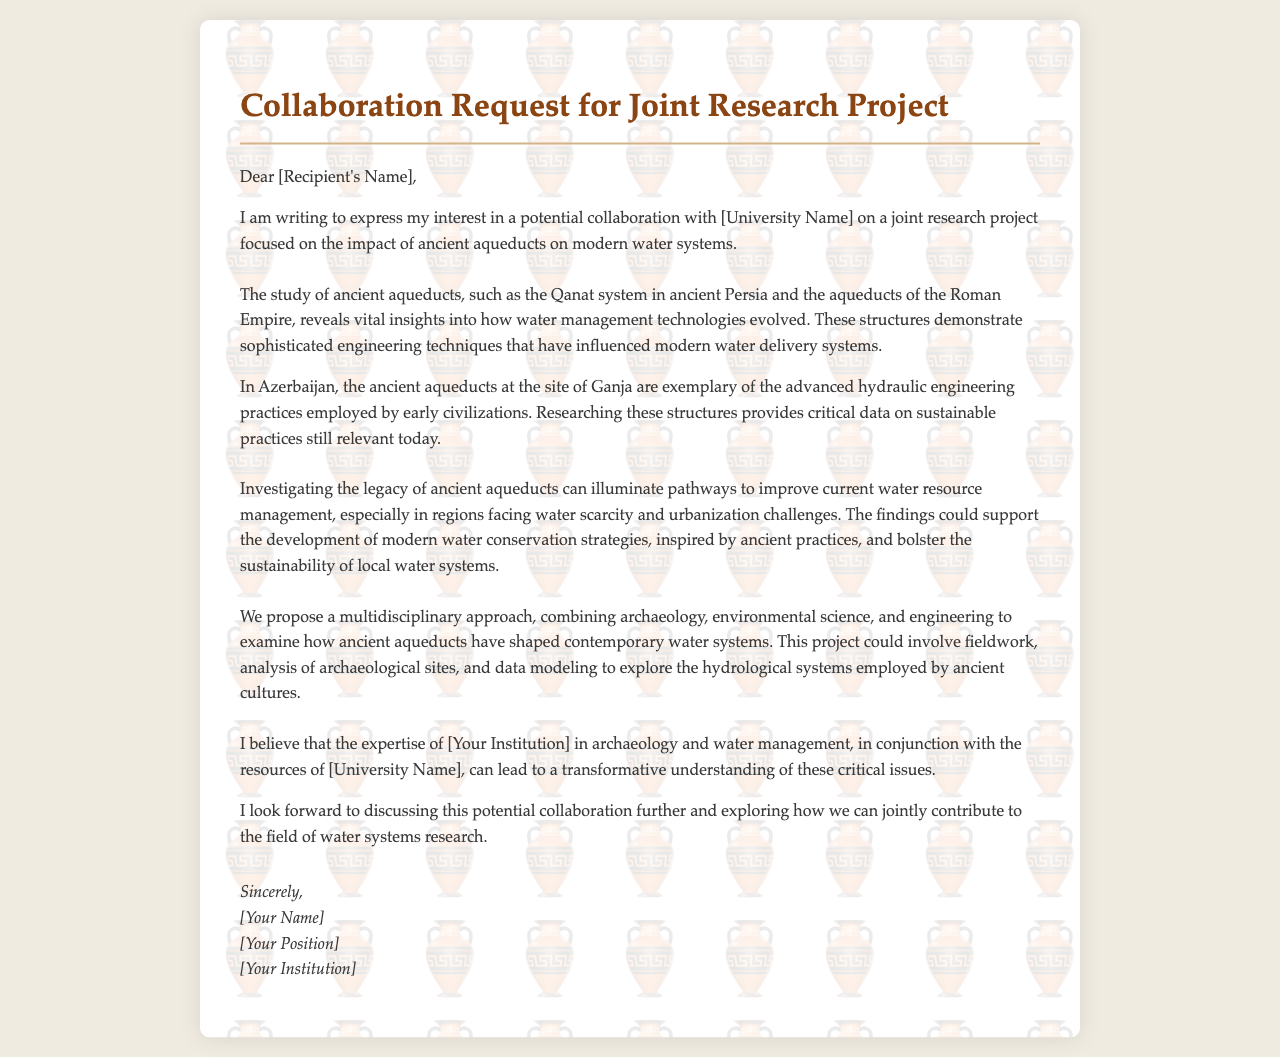What is the title of the document? The title is stated in the heading of the document and is "Collaboration Request for Joint Research Project."
Answer: Collaboration Request for Joint Research Project Who is the letter addressed to? The recipient's name is indicated in the opening line of the letter, which states "Dear [Recipient's Name]."
Answer: [Recipient's Name] What ancient aqueduct system is mentioned in the document? The document refers to ancient aqueduct systems such as the Qanat system in ancient Persia and the aqueducts of the Roman Empire.
Answer: Qanat Which Azerbaijani site is noted for its ancient aqueducts? The site mentioned in relation to ancient aqueducts in Azerbaijan is Ganja.
Answer: Ganja What approach does the letter propose for the research project? The proposed approach for the project is described as multidisciplinary, encompassing various fields such as archaeology, environmental science, and engineering.
Answer: Multidisciplinary approach Why are ancient aqueducts relevant to modern water systems? The letter states that ancient aqueducts can illuminate pathways to improve current water resource management, particularly in addressing challenges like water scarcity.
Answer: Improve water resource management How does the author feel about collaborating with the university? The author expresses a positive outlook towards the collaboration, indicating eagerness to discuss the potential partnership.
Answer: I look forward to discussing this potential collaboration What does the author hope to examine through the proposed project? The author hopes to examine how ancient aqueducts have shaped contemporary water systems through various methods, including fieldwork and data modeling.
Answer: Ancient aqueducts shaping contemporary water systems 